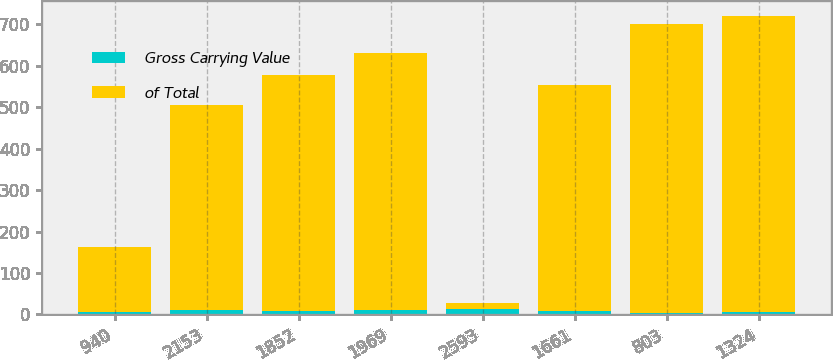Convert chart. <chart><loc_0><loc_0><loc_500><loc_500><stacked_bar_chart><ecel><fcel>940<fcel>2153<fcel>1852<fcel>1969<fcel>2593<fcel>1661<fcel>803<fcel>1324<nl><fcel>Gross Carrying Value<fcel>4.8<fcel>10.9<fcel>9.4<fcel>10<fcel>13.2<fcel>8.4<fcel>4.1<fcel>6.7<nl><fcel>of Total<fcel>157<fcel>495<fcel>568<fcel>621<fcel>13.2<fcel>545<fcel>696<fcel>713<nl></chart> 